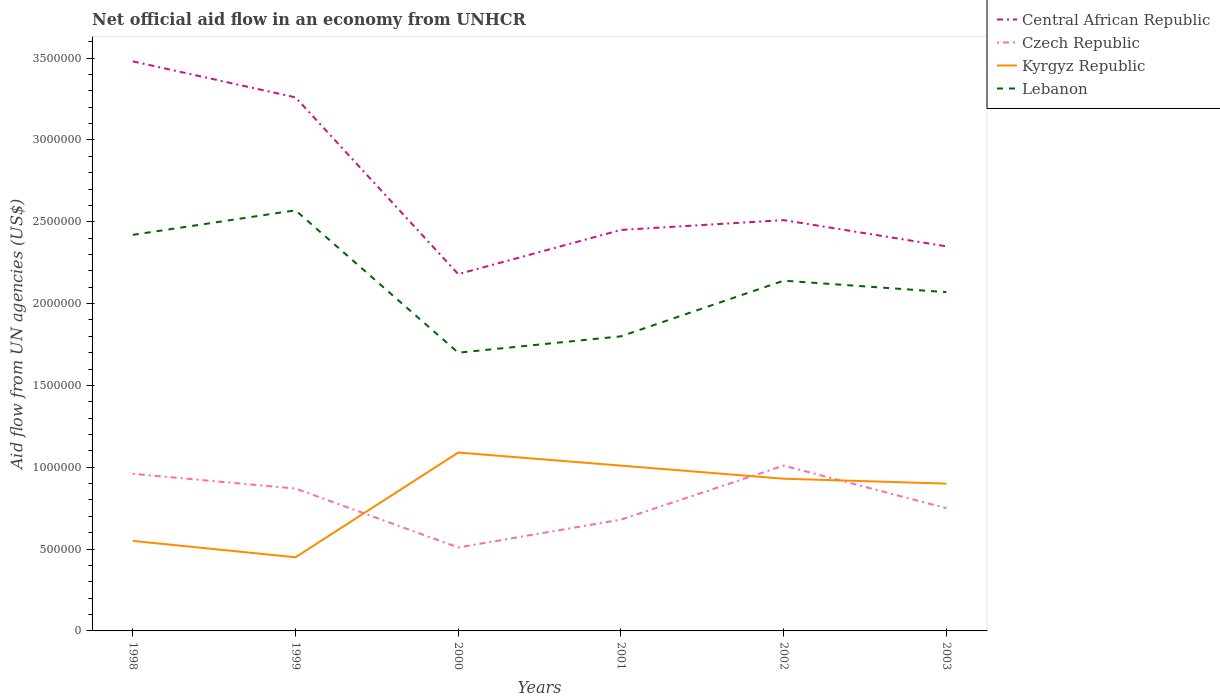Does the line corresponding to Kyrgyz Republic intersect with the line corresponding to Central African Republic?
Your response must be concise. No. Across all years, what is the maximum net official aid flow in Central African Republic?
Your answer should be very brief. 2.18e+06. In which year was the net official aid flow in Central African Republic maximum?
Give a very brief answer. 2000. What is the total net official aid flow in Lebanon in the graph?
Offer a very short reply. 8.70e+05. What is the difference between the highest and the second highest net official aid flow in Central African Republic?
Your answer should be very brief. 1.30e+06. What is the difference between the highest and the lowest net official aid flow in Czech Republic?
Provide a short and direct response. 3. How many lines are there?
Offer a very short reply. 4. How many years are there in the graph?
Provide a succinct answer. 6. What is the difference between two consecutive major ticks on the Y-axis?
Give a very brief answer. 5.00e+05. Does the graph contain any zero values?
Offer a very short reply. No. Does the graph contain grids?
Keep it short and to the point. No. Where does the legend appear in the graph?
Provide a short and direct response. Top right. How many legend labels are there?
Ensure brevity in your answer.  4. What is the title of the graph?
Provide a succinct answer. Net official aid flow in an economy from UNHCR. Does "Tonga" appear as one of the legend labels in the graph?
Make the answer very short. No. What is the label or title of the X-axis?
Your answer should be compact. Years. What is the label or title of the Y-axis?
Keep it short and to the point. Aid flow from UN agencies (US$). What is the Aid flow from UN agencies (US$) in Central African Republic in 1998?
Your answer should be compact. 3.48e+06. What is the Aid flow from UN agencies (US$) of Czech Republic in 1998?
Ensure brevity in your answer.  9.60e+05. What is the Aid flow from UN agencies (US$) of Lebanon in 1998?
Give a very brief answer. 2.42e+06. What is the Aid flow from UN agencies (US$) of Central African Republic in 1999?
Ensure brevity in your answer.  3.26e+06. What is the Aid flow from UN agencies (US$) in Czech Republic in 1999?
Provide a short and direct response. 8.70e+05. What is the Aid flow from UN agencies (US$) of Lebanon in 1999?
Your answer should be very brief. 2.57e+06. What is the Aid flow from UN agencies (US$) of Central African Republic in 2000?
Your response must be concise. 2.18e+06. What is the Aid flow from UN agencies (US$) in Czech Republic in 2000?
Provide a short and direct response. 5.10e+05. What is the Aid flow from UN agencies (US$) of Kyrgyz Republic in 2000?
Offer a terse response. 1.09e+06. What is the Aid flow from UN agencies (US$) in Lebanon in 2000?
Make the answer very short. 1.70e+06. What is the Aid flow from UN agencies (US$) in Central African Republic in 2001?
Make the answer very short. 2.45e+06. What is the Aid flow from UN agencies (US$) in Czech Republic in 2001?
Ensure brevity in your answer.  6.80e+05. What is the Aid flow from UN agencies (US$) of Kyrgyz Republic in 2001?
Provide a short and direct response. 1.01e+06. What is the Aid flow from UN agencies (US$) of Lebanon in 2001?
Your answer should be very brief. 1.80e+06. What is the Aid flow from UN agencies (US$) of Central African Republic in 2002?
Your response must be concise. 2.51e+06. What is the Aid flow from UN agencies (US$) in Czech Republic in 2002?
Make the answer very short. 1.01e+06. What is the Aid flow from UN agencies (US$) of Kyrgyz Republic in 2002?
Your answer should be very brief. 9.30e+05. What is the Aid flow from UN agencies (US$) of Lebanon in 2002?
Give a very brief answer. 2.14e+06. What is the Aid flow from UN agencies (US$) of Central African Republic in 2003?
Make the answer very short. 2.35e+06. What is the Aid flow from UN agencies (US$) of Czech Republic in 2003?
Your answer should be compact. 7.50e+05. What is the Aid flow from UN agencies (US$) of Kyrgyz Republic in 2003?
Your answer should be compact. 9.00e+05. What is the Aid flow from UN agencies (US$) in Lebanon in 2003?
Offer a terse response. 2.07e+06. Across all years, what is the maximum Aid flow from UN agencies (US$) of Central African Republic?
Keep it short and to the point. 3.48e+06. Across all years, what is the maximum Aid flow from UN agencies (US$) of Czech Republic?
Offer a terse response. 1.01e+06. Across all years, what is the maximum Aid flow from UN agencies (US$) of Kyrgyz Republic?
Offer a very short reply. 1.09e+06. Across all years, what is the maximum Aid flow from UN agencies (US$) in Lebanon?
Offer a very short reply. 2.57e+06. Across all years, what is the minimum Aid flow from UN agencies (US$) in Central African Republic?
Ensure brevity in your answer.  2.18e+06. Across all years, what is the minimum Aid flow from UN agencies (US$) of Czech Republic?
Make the answer very short. 5.10e+05. Across all years, what is the minimum Aid flow from UN agencies (US$) of Lebanon?
Provide a succinct answer. 1.70e+06. What is the total Aid flow from UN agencies (US$) in Central African Republic in the graph?
Your answer should be compact. 1.62e+07. What is the total Aid flow from UN agencies (US$) in Czech Republic in the graph?
Your answer should be very brief. 4.78e+06. What is the total Aid flow from UN agencies (US$) of Kyrgyz Republic in the graph?
Your answer should be very brief. 4.93e+06. What is the total Aid flow from UN agencies (US$) in Lebanon in the graph?
Offer a very short reply. 1.27e+07. What is the difference between the Aid flow from UN agencies (US$) of Central African Republic in 1998 and that in 1999?
Provide a succinct answer. 2.20e+05. What is the difference between the Aid flow from UN agencies (US$) in Czech Republic in 1998 and that in 1999?
Make the answer very short. 9.00e+04. What is the difference between the Aid flow from UN agencies (US$) of Lebanon in 1998 and that in 1999?
Give a very brief answer. -1.50e+05. What is the difference between the Aid flow from UN agencies (US$) of Central African Republic in 1998 and that in 2000?
Keep it short and to the point. 1.30e+06. What is the difference between the Aid flow from UN agencies (US$) of Kyrgyz Republic in 1998 and that in 2000?
Offer a very short reply. -5.40e+05. What is the difference between the Aid flow from UN agencies (US$) of Lebanon in 1998 and that in 2000?
Provide a succinct answer. 7.20e+05. What is the difference between the Aid flow from UN agencies (US$) in Central African Republic in 1998 and that in 2001?
Offer a terse response. 1.03e+06. What is the difference between the Aid flow from UN agencies (US$) of Czech Republic in 1998 and that in 2001?
Your answer should be very brief. 2.80e+05. What is the difference between the Aid flow from UN agencies (US$) of Kyrgyz Republic in 1998 and that in 2001?
Provide a succinct answer. -4.60e+05. What is the difference between the Aid flow from UN agencies (US$) in Lebanon in 1998 and that in 2001?
Give a very brief answer. 6.20e+05. What is the difference between the Aid flow from UN agencies (US$) in Central African Republic in 1998 and that in 2002?
Offer a very short reply. 9.70e+05. What is the difference between the Aid flow from UN agencies (US$) of Czech Republic in 1998 and that in 2002?
Offer a terse response. -5.00e+04. What is the difference between the Aid flow from UN agencies (US$) in Kyrgyz Republic in 1998 and that in 2002?
Ensure brevity in your answer.  -3.80e+05. What is the difference between the Aid flow from UN agencies (US$) of Central African Republic in 1998 and that in 2003?
Offer a very short reply. 1.13e+06. What is the difference between the Aid flow from UN agencies (US$) in Kyrgyz Republic in 1998 and that in 2003?
Offer a terse response. -3.50e+05. What is the difference between the Aid flow from UN agencies (US$) in Central African Republic in 1999 and that in 2000?
Offer a very short reply. 1.08e+06. What is the difference between the Aid flow from UN agencies (US$) of Czech Republic in 1999 and that in 2000?
Your answer should be compact. 3.60e+05. What is the difference between the Aid flow from UN agencies (US$) of Kyrgyz Republic in 1999 and that in 2000?
Give a very brief answer. -6.40e+05. What is the difference between the Aid flow from UN agencies (US$) of Lebanon in 1999 and that in 2000?
Offer a very short reply. 8.70e+05. What is the difference between the Aid flow from UN agencies (US$) of Central African Republic in 1999 and that in 2001?
Ensure brevity in your answer.  8.10e+05. What is the difference between the Aid flow from UN agencies (US$) of Kyrgyz Republic in 1999 and that in 2001?
Offer a very short reply. -5.60e+05. What is the difference between the Aid flow from UN agencies (US$) of Lebanon in 1999 and that in 2001?
Ensure brevity in your answer.  7.70e+05. What is the difference between the Aid flow from UN agencies (US$) of Central African Republic in 1999 and that in 2002?
Offer a terse response. 7.50e+05. What is the difference between the Aid flow from UN agencies (US$) in Kyrgyz Republic in 1999 and that in 2002?
Your answer should be very brief. -4.80e+05. What is the difference between the Aid flow from UN agencies (US$) in Lebanon in 1999 and that in 2002?
Your response must be concise. 4.30e+05. What is the difference between the Aid flow from UN agencies (US$) of Central African Republic in 1999 and that in 2003?
Your answer should be very brief. 9.10e+05. What is the difference between the Aid flow from UN agencies (US$) of Kyrgyz Republic in 1999 and that in 2003?
Give a very brief answer. -4.50e+05. What is the difference between the Aid flow from UN agencies (US$) of Lebanon in 1999 and that in 2003?
Offer a terse response. 5.00e+05. What is the difference between the Aid flow from UN agencies (US$) of Lebanon in 2000 and that in 2001?
Ensure brevity in your answer.  -1.00e+05. What is the difference between the Aid flow from UN agencies (US$) of Central African Republic in 2000 and that in 2002?
Offer a terse response. -3.30e+05. What is the difference between the Aid flow from UN agencies (US$) in Czech Republic in 2000 and that in 2002?
Provide a short and direct response. -5.00e+05. What is the difference between the Aid flow from UN agencies (US$) in Lebanon in 2000 and that in 2002?
Provide a succinct answer. -4.40e+05. What is the difference between the Aid flow from UN agencies (US$) of Central African Republic in 2000 and that in 2003?
Offer a very short reply. -1.70e+05. What is the difference between the Aid flow from UN agencies (US$) of Lebanon in 2000 and that in 2003?
Make the answer very short. -3.70e+05. What is the difference between the Aid flow from UN agencies (US$) of Czech Republic in 2001 and that in 2002?
Make the answer very short. -3.30e+05. What is the difference between the Aid flow from UN agencies (US$) in Central African Republic in 2001 and that in 2003?
Offer a terse response. 1.00e+05. What is the difference between the Aid flow from UN agencies (US$) of Kyrgyz Republic in 2001 and that in 2003?
Your answer should be very brief. 1.10e+05. What is the difference between the Aid flow from UN agencies (US$) in Lebanon in 2001 and that in 2003?
Make the answer very short. -2.70e+05. What is the difference between the Aid flow from UN agencies (US$) of Central African Republic in 2002 and that in 2003?
Provide a short and direct response. 1.60e+05. What is the difference between the Aid flow from UN agencies (US$) in Kyrgyz Republic in 2002 and that in 2003?
Keep it short and to the point. 3.00e+04. What is the difference between the Aid flow from UN agencies (US$) in Lebanon in 2002 and that in 2003?
Offer a very short reply. 7.00e+04. What is the difference between the Aid flow from UN agencies (US$) in Central African Republic in 1998 and the Aid flow from UN agencies (US$) in Czech Republic in 1999?
Your answer should be compact. 2.61e+06. What is the difference between the Aid flow from UN agencies (US$) of Central African Republic in 1998 and the Aid flow from UN agencies (US$) of Kyrgyz Republic in 1999?
Your answer should be compact. 3.03e+06. What is the difference between the Aid flow from UN agencies (US$) in Central African Republic in 1998 and the Aid flow from UN agencies (US$) in Lebanon in 1999?
Keep it short and to the point. 9.10e+05. What is the difference between the Aid flow from UN agencies (US$) in Czech Republic in 1998 and the Aid flow from UN agencies (US$) in Kyrgyz Republic in 1999?
Ensure brevity in your answer.  5.10e+05. What is the difference between the Aid flow from UN agencies (US$) of Czech Republic in 1998 and the Aid flow from UN agencies (US$) of Lebanon in 1999?
Your response must be concise. -1.61e+06. What is the difference between the Aid flow from UN agencies (US$) of Kyrgyz Republic in 1998 and the Aid flow from UN agencies (US$) of Lebanon in 1999?
Your response must be concise. -2.02e+06. What is the difference between the Aid flow from UN agencies (US$) of Central African Republic in 1998 and the Aid flow from UN agencies (US$) of Czech Republic in 2000?
Give a very brief answer. 2.97e+06. What is the difference between the Aid flow from UN agencies (US$) in Central African Republic in 1998 and the Aid flow from UN agencies (US$) in Kyrgyz Republic in 2000?
Give a very brief answer. 2.39e+06. What is the difference between the Aid flow from UN agencies (US$) in Central African Republic in 1998 and the Aid flow from UN agencies (US$) in Lebanon in 2000?
Provide a succinct answer. 1.78e+06. What is the difference between the Aid flow from UN agencies (US$) of Czech Republic in 1998 and the Aid flow from UN agencies (US$) of Kyrgyz Republic in 2000?
Your answer should be compact. -1.30e+05. What is the difference between the Aid flow from UN agencies (US$) in Czech Republic in 1998 and the Aid flow from UN agencies (US$) in Lebanon in 2000?
Your answer should be compact. -7.40e+05. What is the difference between the Aid flow from UN agencies (US$) in Kyrgyz Republic in 1998 and the Aid flow from UN agencies (US$) in Lebanon in 2000?
Offer a terse response. -1.15e+06. What is the difference between the Aid flow from UN agencies (US$) of Central African Republic in 1998 and the Aid flow from UN agencies (US$) of Czech Republic in 2001?
Offer a terse response. 2.80e+06. What is the difference between the Aid flow from UN agencies (US$) in Central African Republic in 1998 and the Aid flow from UN agencies (US$) in Kyrgyz Republic in 2001?
Provide a succinct answer. 2.47e+06. What is the difference between the Aid flow from UN agencies (US$) in Central African Republic in 1998 and the Aid flow from UN agencies (US$) in Lebanon in 2001?
Give a very brief answer. 1.68e+06. What is the difference between the Aid flow from UN agencies (US$) in Czech Republic in 1998 and the Aid flow from UN agencies (US$) in Lebanon in 2001?
Your response must be concise. -8.40e+05. What is the difference between the Aid flow from UN agencies (US$) in Kyrgyz Republic in 1998 and the Aid flow from UN agencies (US$) in Lebanon in 2001?
Your answer should be very brief. -1.25e+06. What is the difference between the Aid flow from UN agencies (US$) of Central African Republic in 1998 and the Aid flow from UN agencies (US$) of Czech Republic in 2002?
Ensure brevity in your answer.  2.47e+06. What is the difference between the Aid flow from UN agencies (US$) in Central African Republic in 1998 and the Aid flow from UN agencies (US$) in Kyrgyz Republic in 2002?
Offer a very short reply. 2.55e+06. What is the difference between the Aid flow from UN agencies (US$) of Central African Republic in 1998 and the Aid flow from UN agencies (US$) of Lebanon in 2002?
Keep it short and to the point. 1.34e+06. What is the difference between the Aid flow from UN agencies (US$) of Czech Republic in 1998 and the Aid flow from UN agencies (US$) of Lebanon in 2002?
Provide a short and direct response. -1.18e+06. What is the difference between the Aid flow from UN agencies (US$) of Kyrgyz Republic in 1998 and the Aid flow from UN agencies (US$) of Lebanon in 2002?
Keep it short and to the point. -1.59e+06. What is the difference between the Aid flow from UN agencies (US$) in Central African Republic in 1998 and the Aid flow from UN agencies (US$) in Czech Republic in 2003?
Give a very brief answer. 2.73e+06. What is the difference between the Aid flow from UN agencies (US$) in Central African Republic in 1998 and the Aid flow from UN agencies (US$) in Kyrgyz Republic in 2003?
Offer a terse response. 2.58e+06. What is the difference between the Aid flow from UN agencies (US$) in Central African Republic in 1998 and the Aid flow from UN agencies (US$) in Lebanon in 2003?
Ensure brevity in your answer.  1.41e+06. What is the difference between the Aid flow from UN agencies (US$) of Czech Republic in 1998 and the Aid flow from UN agencies (US$) of Kyrgyz Republic in 2003?
Your answer should be compact. 6.00e+04. What is the difference between the Aid flow from UN agencies (US$) in Czech Republic in 1998 and the Aid flow from UN agencies (US$) in Lebanon in 2003?
Your answer should be very brief. -1.11e+06. What is the difference between the Aid flow from UN agencies (US$) in Kyrgyz Republic in 1998 and the Aid flow from UN agencies (US$) in Lebanon in 2003?
Your response must be concise. -1.52e+06. What is the difference between the Aid flow from UN agencies (US$) of Central African Republic in 1999 and the Aid flow from UN agencies (US$) of Czech Republic in 2000?
Provide a short and direct response. 2.75e+06. What is the difference between the Aid flow from UN agencies (US$) of Central African Republic in 1999 and the Aid flow from UN agencies (US$) of Kyrgyz Republic in 2000?
Your answer should be compact. 2.17e+06. What is the difference between the Aid flow from UN agencies (US$) of Central African Republic in 1999 and the Aid flow from UN agencies (US$) of Lebanon in 2000?
Give a very brief answer. 1.56e+06. What is the difference between the Aid flow from UN agencies (US$) of Czech Republic in 1999 and the Aid flow from UN agencies (US$) of Kyrgyz Republic in 2000?
Provide a short and direct response. -2.20e+05. What is the difference between the Aid flow from UN agencies (US$) in Czech Republic in 1999 and the Aid flow from UN agencies (US$) in Lebanon in 2000?
Ensure brevity in your answer.  -8.30e+05. What is the difference between the Aid flow from UN agencies (US$) of Kyrgyz Republic in 1999 and the Aid flow from UN agencies (US$) of Lebanon in 2000?
Offer a terse response. -1.25e+06. What is the difference between the Aid flow from UN agencies (US$) in Central African Republic in 1999 and the Aid flow from UN agencies (US$) in Czech Republic in 2001?
Provide a short and direct response. 2.58e+06. What is the difference between the Aid flow from UN agencies (US$) in Central African Republic in 1999 and the Aid flow from UN agencies (US$) in Kyrgyz Republic in 2001?
Ensure brevity in your answer.  2.25e+06. What is the difference between the Aid flow from UN agencies (US$) of Central African Republic in 1999 and the Aid flow from UN agencies (US$) of Lebanon in 2001?
Give a very brief answer. 1.46e+06. What is the difference between the Aid flow from UN agencies (US$) of Czech Republic in 1999 and the Aid flow from UN agencies (US$) of Kyrgyz Republic in 2001?
Your answer should be compact. -1.40e+05. What is the difference between the Aid flow from UN agencies (US$) in Czech Republic in 1999 and the Aid flow from UN agencies (US$) in Lebanon in 2001?
Offer a very short reply. -9.30e+05. What is the difference between the Aid flow from UN agencies (US$) of Kyrgyz Republic in 1999 and the Aid flow from UN agencies (US$) of Lebanon in 2001?
Provide a short and direct response. -1.35e+06. What is the difference between the Aid flow from UN agencies (US$) in Central African Republic in 1999 and the Aid flow from UN agencies (US$) in Czech Republic in 2002?
Your answer should be very brief. 2.25e+06. What is the difference between the Aid flow from UN agencies (US$) of Central African Republic in 1999 and the Aid flow from UN agencies (US$) of Kyrgyz Republic in 2002?
Offer a very short reply. 2.33e+06. What is the difference between the Aid flow from UN agencies (US$) of Central African Republic in 1999 and the Aid flow from UN agencies (US$) of Lebanon in 2002?
Make the answer very short. 1.12e+06. What is the difference between the Aid flow from UN agencies (US$) of Czech Republic in 1999 and the Aid flow from UN agencies (US$) of Lebanon in 2002?
Provide a short and direct response. -1.27e+06. What is the difference between the Aid flow from UN agencies (US$) in Kyrgyz Republic in 1999 and the Aid flow from UN agencies (US$) in Lebanon in 2002?
Your answer should be very brief. -1.69e+06. What is the difference between the Aid flow from UN agencies (US$) in Central African Republic in 1999 and the Aid flow from UN agencies (US$) in Czech Republic in 2003?
Your response must be concise. 2.51e+06. What is the difference between the Aid flow from UN agencies (US$) of Central African Republic in 1999 and the Aid flow from UN agencies (US$) of Kyrgyz Republic in 2003?
Your answer should be compact. 2.36e+06. What is the difference between the Aid flow from UN agencies (US$) of Central African Republic in 1999 and the Aid flow from UN agencies (US$) of Lebanon in 2003?
Your answer should be very brief. 1.19e+06. What is the difference between the Aid flow from UN agencies (US$) in Czech Republic in 1999 and the Aid flow from UN agencies (US$) in Lebanon in 2003?
Your response must be concise. -1.20e+06. What is the difference between the Aid flow from UN agencies (US$) in Kyrgyz Republic in 1999 and the Aid flow from UN agencies (US$) in Lebanon in 2003?
Offer a very short reply. -1.62e+06. What is the difference between the Aid flow from UN agencies (US$) of Central African Republic in 2000 and the Aid flow from UN agencies (US$) of Czech Republic in 2001?
Your response must be concise. 1.50e+06. What is the difference between the Aid flow from UN agencies (US$) in Central African Republic in 2000 and the Aid flow from UN agencies (US$) in Kyrgyz Republic in 2001?
Offer a very short reply. 1.17e+06. What is the difference between the Aid flow from UN agencies (US$) of Central African Republic in 2000 and the Aid flow from UN agencies (US$) of Lebanon in 2001?
Your response must be concise. 3.80e+05. What is the difference between the Aid flow from UN agencies (US$) of Czech Republic in 2000 and the Aid flow from UN agencies (US$) of Kyrgyz Republic in 2001?
Your answer should be compact. -5.00e+05. What is the difference between the Aid flow from UN agencies (US$) in Czech Republic in 2000 and the Aid flow from UN agencies (US$) in Lebanon in 2001?
Offer a very short reply. -1.29e+06. What is the difference between the Aid flow from UN agencies (US$) in Kyrgyz Republic in 2000 and the Aid flow from UN agencies (US$) in Lebanon in 2001?
Provide a short and direct response. -7.10e+05. What is the difference between the Aid flow from UN agencies (US$) in Central African Republic in 2000 and the Aid flow from UN agencies (US$) in Czech Republic in 2002?
Provide a succinct answer. 1.17e+06. What is the difference between the Aid flow from UN agencies (US$) of Central African Republic in 2000 and the Aid flow from UN agencies (US$) of Kyrgyz Republic in 2002?
Keep it short and to the point. 1.25e+06. What is the difference between the Aid flow from UN agencies (US$) of Czech Republic in 2000 and the Aid flow from UN agencies (US$) of Kyrgyz Republic in 2002?
Provide a succinct answer. -4.20e+05. What is the difference between the Aid flow from UN agencies (US$) in Czech Republic in 2000 and the Aid flow from UN agencies (US$) in Lebanon in 2002?
Provide a succinct answer. -1.63e+06. What is the difference between the Aid flow from UN agencies (US$) of Kyrgyz Republic in 2000 and the Aid flow from UN agencies (US$) of Lebanon in 2002?
Ensure brevity in your answer.  -1.05e+06. What is the difference between the Aid flow from UN agencies (US$) of Central African Republic in 2000 and the Aid flow from UN agencies (US$) of Czech Republic in 2003?
Offer a terse response. 1.43e+06. What is the difference between the Aid flow from UN agencies (US$) in Central African Republic in 2000 and the Aid flow from UN agencies (US$) in Kyrgyz Republic in 2003?
Your answer should be very brief. 1.28e+06. What is the difference between the Aid flow from UN agencies (US$) in Czech Republic in 2000 and the Aid flow from UN agencies (US$) in Kyrgyz Republic in 2003?
Make the answer very short. -3.90e+05. What is the difference between the Aid flow from UN agencies (US$) of Czech Republic in 2000 and the Aid flow from UN agencies (US$) of Lebanon in 2003?
Give a very brief answer. -1.56e+06. What is the difference between the Aid flow from UN agencies (US$) of Kyrgyz Republic in 2000 and the Aid flow from UN agencies (US$) of Lebanon in 2003?
Keep it short and to the point. -9.80e+05. What is the difference between the Aid flow from UN agencies (US$) of Central African Republic in 2001 and the Aid flow from UN agencies (US$) of Czech Republic in 2002?
Make the answer very short. 1.44e+06. What is the difference between the Aid flow from UN agencies (US$) in Central African Republic in 2001 and the Aid flow from UN agencies (US$) in Kyrgyz Republic in 2002?
Provide a short and direct response. 1.52e+06. What is the difference between the Aid flow from UN agencies (US$) in Central African Republic in 2001 and the Aid flow from UN agencies (US$) in Lebanon in 2002?
Provide a succinct answer. 3.10e+05. What is the difference between the Aid flow from UN agencies (US$) of Czech Republic in 2001 and the Aid flow from UN agencies (US$) of Kyrgyz Republic in 2002?
Provide a succinct answer. -2.50e+05. What is the difference between the Aid flow from UN agencies (US$) of Czech Republic in 2001 and the Aid flow from UN agencies (US$) of Lebanon in 2002?
Ensure brevity in your answer.  -1.46e+06. What is the difference between the Aid flow from UN agencies (US$) of Kyrgyz Republic in 2001 and the Aid flow from UN agencies (US$) of Lebanon in 2002?
Your response must be concise. -1.13e+06. What is the difference between the Aid flow from UN agencies (US$) of Central African Republic in 2001 and the Aid flow from UN agencies (US$) of Czech Republic in 2003?
Your answer should be compact. 1.70e+06. What is the difference between the Aid flow from UN agencies (US$) in Central African Republic in 2001 and the Aid flow from UN agencies (US$) in Kyrgyz Republic in 2003?
Ensure brevity in your answer.  1.55e+06. What is the difference between the Aid flow from UN agencies (US$) in Central African Republic in 2001 and the Aid flow from UN agencies (US$) in Lebanon in 2003?
Your answer should be very brief. 3.80e+05. What is the difference between the Aid flow from UN agencies (US$) of Czech Republic in 2001 and the Aid flow from UN agencies (US$) of Kyrgyz Republic in 2003?
Keep it short and to the point. -2.20e+05. What is the difference between the Aid flow from UN agencies (US$) in Czech Republic in 2001 and the Aid flow from UN agencies (US$) in Lebanon in 2003?
Ensure brevity in your answer.  -1.39e+06. What is the difference between the Aid flow from UN agencies (US$) of Kyrgyz Republic in 2001 and the Aid flow from UN agencies (US$) of Lebanon in 2003?
Offer a terse response. -1.06e+06. What is the difference between the Aid flow from UN agencies (US$) of Central African Republic in 2002 and the Aid flow from UN agencies (US$) of Czech Republic in 2003?
Your response must be concise. 1.76e+06. What is the difference between the Aid flow from UN agencies (US$) of Central African Republic in 2002 and the Aid flow from UN agencies (US$) of Kyrgyz Republic in 2003?
Your response must be concise. 1.61e+06. What is the difference between the Aid flow from UN agencies (US$) of Czech Republic in 2002 and the Aid flow from UN agencies (US$) of Kyrgyz Republic in 2003?
Your response must be concise. 1.10e+05. What is the difference between the Aid flow from UN agencies (US$) in Czech Republic in 2002 and the Aid flow from UN agencies (US$) in Lebanon in 2003?
Your answer should be compact. -1.06e+06. What is the difference between the Aid flow from UN agencies (US$) of Kyrgyz Republic in 2002 and the Aid flow from UN agencies (US$) of Lebanon in 2003?
Ensure brevity in your answer.  -1.14e+06. What is the average Aid flow from UN agencies (US$) of Central African Republic per year?
Ensure brevity in your answer.  2.70e+06. What is the average Aid flow from UN agencies (US$) in Czech Republic per year?
Keep it short and to the point. 7.97e+05. What is the average Aid flow from UN agencies (US$) of Kyrgyz Republic per year?
Provide a short and direct response. 8.22e+05. What is the average Aid flow from UN agencies (US$) in Lebanon per year?
Provide a short and direct response. 2.12e+06. In the year 1998, what is the difference between the Aid flow from UN agencies (US$) of Central African Republic and Aid flow from UN agencies (US$) of Czech Republic?
Keep it short and to the point. 2.52e+06. In the year 1998, what is the difference between the Aid flow from UN agencies (US$) of Central African Republic and Aid flow from UN agencies (US$) of Kyrgyz Republic?
Provide a short and direct response. 2.93e+06. In the year 1998, what is the difference between the Aid flow from UN agencies (US$) in Central African Republic and Aid flow from UN agencies (US$) in Lebanon?
Give a very brief answer. 1.06e+06. In the year 1998, what is the difference between the Aid flow from UN agencies (US$) of Czech Republic and Aid flow from UN agencies (US$) of Kyrgyz Republic?
Provide a succinct answer. 4.10e+05. In the year 1998, what is the difference between the Aid flow from UN agencies (US$) of Czech Republic and Aid flow from UN agencies (US$) of Lebanon?
Keep it short and to the point. -1.46e+06. In the year 1998, what is the difference between the Aid flow from UN agencies (US$) of Kyrgyz Republic and Aid flow from UN agencies (US$) of Lebanon?
Make the answer very short. -1.87e+06. In the year 1999, what is the difference between the Aid flow from UN agencies (US$) in Central African Republic and Aid flow from UN agencies (US$) in Czech Republic?
Provide a succinct answer. 2.39e+06. In the year 1999, what is the difference between the Aid flow from UN agencies (US$) in Central African Republic and Aid flow from UN agencies (US$) in Kyrgyz Republic?
Offer a terse response. 2.81e+06. In the year 1999, what is the difference between the Aid flow from UN agencies (US$) of Central African Republic and Aid flow from UN agencies (US$) of Lebanon?
Make the answer very short. 6.90e+05. In the year 1999, what is the difference between the Aid flow from UN agencies (US$) in Czech Republic and Aid flow from UN agencies (US$) in Lebanon?
Provide a succinct answer. -1.70e+06. In the year 1999, what is the difference between the Aid flow from UN agencies (US$) in Kyrgyz Republic and Aid flow from UN agencies (US$) in Lebanon?
Your answer should be compact. -2.12e+06. In the year 2000, what is the difference between the Aid flow from UN agencies (US$) of Central African Republic and Aid flow from UN agencies (US$) of Czech Republic?
Your answer should be compact. 1.67e+06. In the year 2000, what is the difference between the Aid flow from UN agencies (US$) in Central African Republic and Aid flow from UN agencies (US$) in Kyrgyz Republic?
Your response must be concise. 1.09e+06. In the year 2000, what is the difference between the Aid flow from UN agencies (US$) in Czech Republic and Aid flow from UN agencies (US$) in Kyrgyz Republic?
Offer a terse response. -5.80e+05. In the year 2000, what is the difference between the Aid flow from UN agencies (US$) of Czech Republic and Aid flow from UN agencies (US$) of Lebanon?
Offer a terse response. -1.19e+06. In the year 2000, what is the difference between the Aid flow from UN agencies (US$) of Kyrgyz Republic and Aid flow from UN agencies (US$) of Lebanon?
Make the answer very short. -6.10e+05. In the year 2001, what is the difference between the Aid flow from UN agencies (US$) in Central African Republic and Aid flow from UN agencies (US$) in Czech Republic?
Ensure brevity in your answer.  1.77e+06. In the year 2001, what is the difference between the Aid flow from UN agencies (US$) in Central African Republic and Aid flow from UN agencies (US$) in Kyrgyz Republic?
Offer a very short reply. 1.44e+06. In the year 2001, what is the difference between the Aid flow from UN agencies (US$) in Central African Republic and Aid flow from UN agencies (US$) in Lebanon?
Provide a succinct answer. 6.50e+05. In the year 2001, what is the difference between the Aid flow from UN agencies (US$) of Czech Republic and Aid flow from UN agencies (US$) of Kyrgyz Republic?
Provide a succinct answer. -3.30e+05. In the year 2001, what is the difference between the Aid flow from UN agencies (US$) in Czech Republic and Aid flow from UN agencies (US$) in Lebanon?
Keep it short and to the point. -1.12e+06. In the year 2001, what is the difference between the Aid flow from UN agencies (US$) of Kyrgyz Republic and Aid flow from UN agencies (US$) of Lebanon?
Give a very brief answer. -7.90e+05. In the year 2002, what is the difference between the Aid flow from UN agencies (US$) of Central African Republic and Aid flow from UN agencies (US$) of Czech Republic?
Make the answer very short. 1.50e+06. In the year 2002, what is the difference between the Aid flow from UN agencies (US$) in Central African Republic and Aid flow from UN agencies (US$) in Kyrgyz Republic?
Your answer should be very brief. 1.58e+06. In the year 2002, what is the difference between the Aid flow from UN agencies (US$) in Czech Republic and Aid flow from UN agencies (US$) in Lebanon?
Ensure brevity in your answer.  -1.13e+06. In the year 2002, what is the difference between the Aid flow from UN agencies (US$) of Kyrgyz Republic and Aid flow from UN agencies (US$) of Lebanon?
Give a very brief answer. -1.21e+06. In the year 2003, what is the difference between the Aid flow from UN agencies (US$) in Central African Republic and Aid flow from UN agencies (US$) in Czech Republic?
Give a very brief answer. 1.60e+06. In the year 2003, what is the difference between the Aid flow from UN agencies (US$) in Central African Republic and Aid flow from UN agencies (US$) in Kyrgyz Republic?
Offer a very short reply. 1.45e+06. In the year 2003, what is the difference between the Aid flow from UN agencies (US$) in Central African Republic and Aid flow from UN agencies (US$) in Lebanon?
Offer a terse response. 2.80e+05. In the year 2003, what is the difference between the Aid flow from UN agencies (US$) of Czech Republic and Aid flow from UN agencies (US$) of Kyrgyz Republic?
Make the answer very short. -1.50e+05. In the year 2003, what is the difference between the Aid flow from UN agencies (US$) in Czech Republic and Aid flow from UN agencies (US$) in Lebanon?
Make the answer very short. -1.32e+06. In the year 2003, what is the difference between the Aid flow from UN agencies (US$) in Kyrgyz Republic and Aid flow from UN agencies (US$) in Lebanon?
Offer a terse response. -1.17e+06. What is the ratio of the Aid flow from UN agencies (US$) of Central African Republic in 1998 to that in 1999?
Offer a terse response. 1.07. What is the ratio of the Aid flow from UN agencies (US$) of Czech Republic in 1998 to that in 1999?
Keep it short and to the point. 1.1. What is the ratio of the Aid flow from UN agencies (US$) of Kyrgyz Republic in 1998 to that in 1999?
Make the answer very short. 1.22. What is the ratio of the Aid flow from UN agencies (US$) in Lebanon in 1998 to that in 1999?
Provide a succinct answer. 0.94. What is the ratio of the Aid flow from UN agencies (US$) of Central African Republic in 1998 to that in 2000?
Provide a succinct answer. 1.6. What is the ratio of the Aid flow from UN agencies (US$) of Czech Republic in 1998 to that in 2000?
Ensure brevity in your answer.  1.88. What is the ratio of the Aid flow from UN agencies (US$) of Kyrgyz Republic in 1998 to that in 2000?
Provide a short and direct response. 0.5. What is the ratio of the Aid flow from UN agencies (US$) of Lebanon in 1998 to that in 2000?
Provide a short and direct response. 1.42. What is the ratio of the Aid flow from UN agencies (US$) of Central African Republic in 1998 to that in 2001?
Your response must be concise. 1.42. What is the ratio of the Aid flow from UN agencies (US$) in Czech Republic in 1998 to that in 2001?
Your answer should be very brief. 1.41. What is the ratio of the Aid flow from UN agencies (US$) of Kyrgyz Republic in 1998 to that in 2001?
Your response must be concise. 0.54. What is the ratio of the Aid flow from UN agencies (US$) of Lebanon in 1998 to that in 2001?
Provide a short and direct response. 1.34. What is the ratio of the Aid flow from UN agencies (US$) of Central African Republic in 1998 to that in 2002?
Ensure brevity in your answer.  1.39. What is the ratio of the Aid flow from UN agencies (US$) in Czech Republic in 1998 to that in 2002?
Provide a short and direct response. 0.95. What is the ratio of the Aid flow from UN agencies (US$) in Kyrgyz Republic in 1998 to that in 2002?
Your answer should be compact. 0.59. What is the ratio of the Aid flow from UN agencies (US$) of Lebanon in 1998 to that in 2002?
Provide a short and direct response. 1.13. What is the ratio of the Aid flow from UN agencies (US$) in Central African Republic in 1998 to that in 2003?
Your response must be concise. 1.48. What is the ratio of the Aid flow from UN agencies (US$) of Czech Republic in 1998 to that in 2003?
Offer a terse response. 1.28. What is the ratio of the Aid flow from UN agencies (US$) of Kyrgyz Republic in 1998 to that in 2003?
Ensure brevity in your answer.  0.61. What is the ratio of the Aid flow from UN agencies (US$) in Lebanon in 1998 to that in 2003?
Your answer should be very brief. 1.17. What is the ratio of the Aid flow from UN agencies (US$) of Central African Republic in 1999 to that in 2000?
Your answer should be very brief. 1.5. What is the ratio of the Aid flow from UN agencies (US$) in Czech Republic in 1999 to that in 2000?
Your response must be concise. 1.71. What is the ratio of the Aid flow from UN agencies (US$) in Kyrgyz Republic in 1999 to that in 2000?
Give a very brief answer. 0.41. What is the ratio of the Aid flow from UN agencies (US$) of Lebanon in 1999 to that in 2000?
Offer a very short reply. 1.51. What is the ratio of the Aid flow from UN agencies (US$) of Central African Republic in 1999 to that in 2001?
Provide a short and direct response. 1.33. What is the ratio of the Aid flow from UN agencies (US$) of Czech Republic in 1999 to that in 2001?
Make the answer very short. 1.28. What is the ratio of the Aid flow from UN agencies (US$) in Kyrgyz Republic in 1999 to that in 2001?
Ensure brevity in your answer.  0.45. What is the ratio of the Aid flow from UN agencies (US$) in Lebanon in 1999 to that in 2001?
Your response must be concise. 1.43. What is the ratio of the Aid flow from UN agencies (US$) of Central African Republic in 1999 to that in 2002?
Your answer should be very brief. 1.3. What is the ratio of the Aid flow from UN agencies (US$) of Czech Republic in 1999 to that in 2002?
Make the answer very short. 0.86. What is the ratio of the Aid flow from UN agencies (US$) of Kyrgyz Republic in 1999 to that in 2002?
Ensure brevity in your answer.  0.48. What is the ratio of the Aid flow from UN agencies (US$) in Lebanon in 1999 to that in 2002?
Provide a succinct answer. 1.2. What is the ratio of the Aid flow from UN agencies (US$) in Central African Republic in 1999 to that in 2003?
Provide a short and direct response. 1.39. What is the ratio of the Aid flow from UN agencies (US$) of Czech Republic in 1999 to that in 2003?
Your answer should be compact. 1.16. What is the ratio of the Aid flow from UN agencies (US$) of Kyrgyz Republic in 1999 to that in 2003?
Your answer should be compact. 0.5. What is the ratio of the Aid flow from UN agencies (US$) of Lebanon in 1999 to that in 2003?
Make the answer very short. 1.24. What is the ratio of the Aid flow from UN agencies (US$) in Central African Republic in 2000 to that in 2001?
Your answer should be very brief. 0.89. What is the ratio of the Aid flow from UN agencies (US$) in Czech Republic in 2000 to that in 2001?
Give a very brief answer. 0.75. What is the ratio of the Aid flow from UN agencies (US$) in Kyrgyz Republic in 2000 to that in 2001?
Offer a very short reply. 1.08. What is the ratio of the Aid flow from UN agencies (US$) in Lebanon in 2000 to that in 2001?
Offer a terse response. 0.94. What is the ratio of the Aid flow from UN agencies (US$) in Central African Republic in 2000 to that in 2002?
Offer a terse response. 0.87. What is the ratio of the Aid flow from UN agencies (US$) of Czech Republic in 2000 to that in 2002?
Your answer should be very brief. 0.51. What is the ratio of the Aid flow from UN agencies (US$) in Kyrgyz Republic in 2000 to that in 2002?
Give a very brief answer. 1.17. What is the ratio of the Aid flow from UN agencies (US$) in Lebanon in 2000 to that in 2002?
Make the answer very short. 0.79. What is the ratio of the Aid flow from UN agencies (US$) in Central African Republic in 2000 to that in 2003?
Offer a terse response. 0.93. What is the ratio of the Aid flow from UN agencies (US$) of Czech Republic in 2000 to that in 2003?
Give a very brief answer. 0.68. What is the ratio of the Aid flow from UN agencies (US$) in Kyrgyz Republic in 2000 to that in 2003?
Provide a succinct answer. 1.21. What is the ratio of the Aid flow from UN agencies (US$) in Lebanon in 2000 to that in 2003?
Keep it short and to the point. 0.82. What is the ratio of the Aid flow from UN agencies (US$) in Central African Republic in 2001 to that in 2002?
Your response must be concise. 0.98. What is the ratio of the Aid flow from UN agencies (US$) in Czech Republic in 2001 to that in 2002?
Provide a succinct answer. 0.67. What is the ratio of the Aid flow from UN agencies (US$) in Kyrgyz Republic in 2001 to that in 2002?
Your answer should be compact. 1.09. What is the ratio of the Aid flow from UN agencies (US$) in Lebanon in 2001 to that in 2002?
Your answer should be compact. 0.84. What is the ratio of the Aid flow from UN agencies (US$) in Central African Republic in 2001 to that in 2003?
Provide a succinct answer. 1.04. What is the ratio of the Aid flow from UN agencies (US$) in Czech Republic in 2001 to that in 2003?
Provide a succinct answer. 0.91. What is the ratio of the Aid flow from UN agencies (US$) of Kyrgyz Republic in 2001 to that in 2003?
Offer a terse response. 1.12. What is the ratio of the Aid flow from UN agencies (US$) of Lebanon in 2001 to that in 2003?
Your answer should be very brief. 0.87. What is the ratio of the Aid flow from UN agencies (US$) in Central African Republic in 2002 to that in 2003?
Your response must be concise. 1.07. What is the ratio of the Aid flow from UN agencies (US$) in Czech Republic in 2002 to that in 2003?
Give a very brief answer. 1.35. What is the ratio of the Aid flow from UN agencies (US$) in Lebanon in 2002 to that in 2003?
Offer a terse response. 1.03. What is the difference between the highest and the second highest Aid flow from UN agencies (US$) of Central African Republic?
Make the answer very short. 2.20e+05. What is the difference between the highest and the second highest Aid flow from UN agencies (US$) of Kyrgyz Republic?
Provide a succinct answer. 8.00e+04. What is the difference between the highest and the second highest Aid flow from UN agencies (US$) of Lebanon?
Give a very brief answer. 1.50e+05. What is the difference between the highest and the lowest Aid flow from UN agencies (US$) in Central African Republic?
Provide a succinct answer. 1.30e+06. What is the difference between the highest and the lowest Aid flow from UN agencies (US$) of Czech Republic?
Offer a terse response. 5.00e+05. What is the difference between the highest and the lowest Aid flow from UN agencies (US$) in Kyrgyz Republic?
Give a very brief answer. 6.40e+05. What is the difference between the highest and the lowest Aid flow from UN agencies (US$) of Lebanon?
Ensure brevity in your answer.  8.70e+05. 